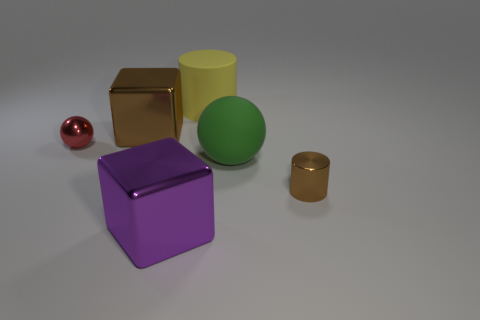There is a yellow rubber object on the right side of the tiny thing to the left of the large yellow matte cylinder; is there a large brown thing that is in front of it?
Provide a succinct answer. Yes. How many tiny red shiny spheres are in front of the big brown thing?
Provide a succinct answer. 1. How many small metallic cylinders are the same color as the large matte sphere?
Offer a terse response. 0. How many things are either big metallic cubes in front of the large brown shiny block or blocks in front of the green object?
Ensure brevity in your answer.  1. Are there more small shiny spheres than blocks?
Your answer should be very brief. No. The big matte thing left of the big sphere is what color?
Your response must be concise. Yellow. Is the shape of the red thing the same as the big green thing?
Your answer should be compact. Yes. What is the color of the shiny object that is right of the shiny ball and behind the small brown cylinder?
Your answer should be very brief. Brown. Do the metallic block in front of the metal cylinder and the ball behind the rubber ball have the same size?
Offer a terse response. No. What number of objects are things to the right of the large yellow cylinder or large metallic things?
Your response must be concise. 4. 